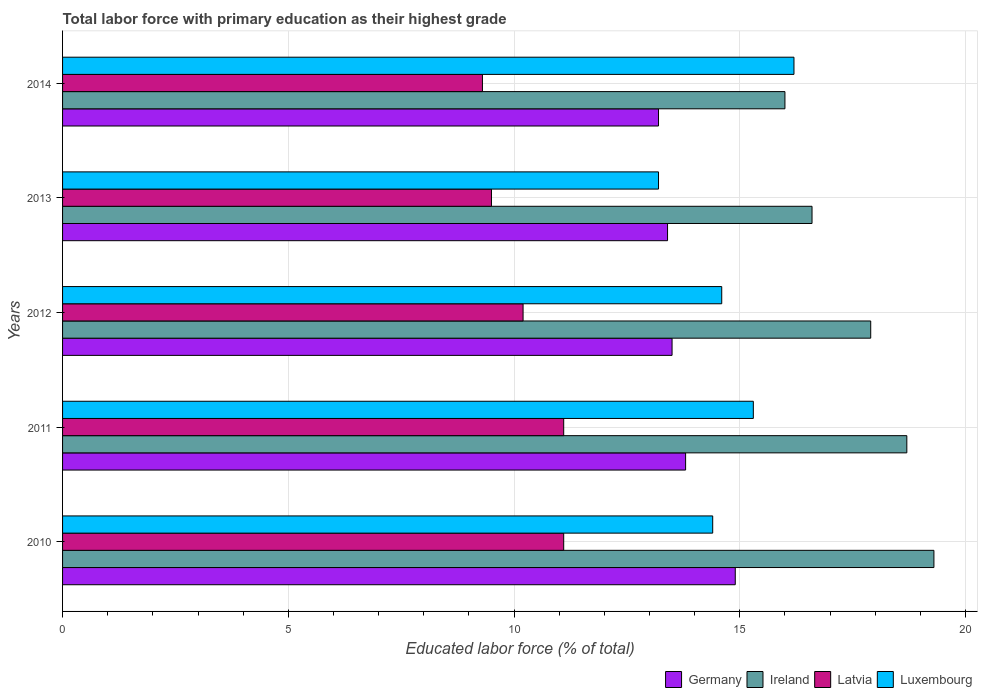How many different coloured bars are there?
Keep it short and to the point. 4. How many groups of bars are there?
Provide a succinct answer. 5. Are the number of bars per tick equal to the number of legend labels?
Your answer should be compact. Yes. Are the number of bars on each tick of the Y-axis equal?
Your response must be concise. Yes. How many bars are there on the 3rd tick from the top?
Your answer should be very brief. 4. How many bars are there on the 5th tick from the bottom?
Provide a short and direct response. 4. What is the label of the 3rd group of bars from the top?
Give a very brief answer. 2012. What is the percentage of total labor force with primary education in Germany in 2010?
Provide a succinct answer. 14.9. Across all years, what is the maximum percentage of total labor force with primary education in Luxembourg?
Offer a very short reply. 16.2. Across all years, what is the minimum percentage of total labor force with primary education in Luxembourg?
Your response must be concise. 13.2. In which year was the percentage of total labor force with primary education in Luxembourg minimum?
Ensure brevity in your answer.  2013. What is the total percentage of total labor force with primary education in Latvia in the graph?
Your response must be concise. 51.2. What is the difference between the percentage of total labor force with primary education in Germany in 2011 and that in 2014?
Offer a terse response. 0.6. What is the difference between the percentage of total labor force with primary education in Ireland in 2011 and the percentage of total labor force with primary education in Luxembourg in 2014?
Your answer should be very brief. 2.5. What is the average percentage of total labor force with primary education in Ireland per year?
Give a very brief answer. 17.7. In the year 2013, what is the difference between the percentage of total labor force with primary education in Latvia and percentage of total labor force with primary education in Luxembourg?
Make the answer very short. -3.7. What is the ratio of the percentage of total labor force with primary education in Luxembourg in 2010 to that in 2014?
Keep it short and to the point. 0.89. What is the difference between the highest and the second highest percentage of total labor force with primary education in Luxembourg?
Your answer should be very brief. 0.9. What is the difference between the highest and the lowest percentage of total labor force with primary education in Luxembourg?
Offer a very short reply. 3. Is the sum of the percentage of total labor force with primary education in Luxembourg in 2013 and 2014 greater than the maximum percentage of total labor force with primary education in Latvia across all years?
Your answer should be compact. Yes. Is it the case that in every year, the sum of the percentage of total labor force with primary education in Latvia and percentage of total labor force with primary education in Ireland is greater than the sum of percentage of total labor force with primary education in Germany and percentage of total labor force with primary education in Luxembourg?
Ensure brevity in your answer.  No. What does the 3rd bar from the top in 2011 represents?
Your answer should be compact. Ireland. What does the 3rd bar from the bottom in 2014 represents?
Offer a very short reply. Latvia. Is it the case that in every year, the sum of the percentage of total labor force with primary education in Germany and percentage of total labor force with primary education in Latvia is greater than the percentage of total labor force with primary education in Luxembourg?
Make the answer very short. Yes. Are all the bars in the graph horizontal?
Ensure brevity in your answer.  Yes. How many years are there in the graph?
Give a very brief answer. 5. Does the graph contain any zero values?
Provide a succinct answer. No. Where does the legend appear in the graph?
Ensure brevity in your answer.  Bottom right. What is the title of the graph?
Provide a succinct answer. Total labor force with primary education as their highest grade. What is the label or title of the X-axis?
Your response must be concise. Educated labor force (% of total). What is the Educated labor force (% of total) of Germany in 2010?
Your answer should be very brief. 14.9. What is the Educated labor force (% of total) of Ireland in 2010?
Your answer should be very brief. 19.3. What is the Educated labor force (% of total) in Latvia in 2010?
Your answer should be very brief. 11.1. What is the Educated labor force (% of total) in Luxembourg in 2010?
Keep it short and to the point. 14.4. What is the Educated labor force (% of total) of Germany in 2011?
Give a very brief answer. 13.8. What is the Educated labor force (% of total) in Ireland in 2011?
Offer a terse response. 18.7. What is the Educated labor force (% of total) of Latvia in 2011?
Your answer should be compact. 11.1. What is the Educated labor force (% of total) of Luxembourg in 2011?
Your answer should be compact. 15.3. What is the Educated labor force (% of total) of Germany in 2012?
Your answer should be compact. 13.5. What is the Educated labor force (% of total) in Ireland in 2012?
Make the answer very short. 17.9. What is the Educated labor force (% of total) in Latvia in 2012?
Provide a short and direct response. 10.2. What is the Educated labor force (% of total) of Luxembourg in 2012?
Make the answer very short. 14.6. What is the Educated labor force (% of total) in Germany in 2013?
Your answer should be very brief. 13.4. What is the Educated labor force (% of total) in Ireland in 2013?
Keep it short and to the point. 16.6. What is the Educated labor force (% of total) of Luxembourg in 2013?
Give a very brief answer. 13.2. What is the Educated labor force (% of total) of Germany in 2014?
Give a very brief answer. 13.2. What is the Educated labor force (% of total) of Latvia in 2014?
Offer a terse response. 9.3. What is the Educated labor force (% of total) in Luxembourg in 2014?
Your answer should be compact. 16.2. Across all years, what is the maximum Educated labor force (% of total) of Germany?
Offer a very short reply. 14.9. Across all years, what is the maximum Educated labor force (% of total) of Ireland?
Make the answer very short. 19.3. Across all years, what is the maximum Educated labor force (% of total) of Latvia?
Offer a terse response. 11.1. Across all years, what is the maximum Educated labor force (% of total) of Luxembourg?
Give a very brief answer. 16.2. Across all years, what is the minimum Educated labor force (% of total) in Germany?
Your answer should be compact. 13.2. Across all years, what is the minimum Educated labor force (% of total) of Ireland?
Make the answer very short. 16. Across all years, what is the minimum Educated labor force (% of total) in Latvia?
Your answer should be compact. 9.3. Across all years, what is the minimum Educated labor force (% of total) in Luxembourg?
Your response must be concise. 13.2. What is the total Educated labor force (% of total) in Germany in the graph?
Provide a short and direct response. 68.8. What is the total Educated labor force (% of total) of Ireland in the graph?
Offer a terse response. 88.5. What is the total Educated labor force (% of total) of Latvia in the graph?
Provide a short and direct response. 51.2. What is the total Educated labor force (% of total) of Luxembourg in the graph?
Your response must be concise. 73.7. What is the difference between the Educated labor force (% of total) in Germany in 2010 and that in 2011?
Make the answer very short. 1.1. What is the difference between the Educated labor force (% of total) in Latvia in 2010 and that in 2011?
Provide a short and direct response. 0. What is the difference between the Educated labor force (% of total) in Germany in 2010 and that in 2013?
Provide a succinct answer. 1.5. What is the difference between the Educated labor force (% of total) of Latvia in 2010 and that in 2013?
Your response must be concise. 1.6. What is the difference between the Educated labor force (% of total) in Luxembourg in 2010 and that in 2013?
Offer a terse response. 1.2. What is the difference between the Educated labor force (% of total) of Ireland in 2010 and that in 2014?
Ensure brevity in your answer.  3.3. What is the difference between the Educated labor force (% of total) in Germany in 2011 and that in 2012?
Offer a very short reply. 0.3. What is the difference between the Educated labor force (% of total) in Latvia in 2011 and that in 2012?
Provide a short and direct response. 0.9. What is the difference between the Educated labor force (% of total) in Luxembourg in 2011 and that in 2012?
Ensure brevity in your answer.  0.7. What is the difference between the Educated labor force (% of total) of Ireland in 2011 and that in 2014?
Make the answer very short. 2.7. What is the difference between the Educated labor force (% of total) of Germany in 2012 and that in 2013?
Offer a very short reply. 0.1. What is the difference between the Educated labor force (% of total) of Latvia in 2012 and that in 2014?
Give a very brief answer. 0.9. What is the difference between the Educated labor force (% of total) in Luxembourg in 2012 and that in 2014?
Your answer should be very brief. -1.6. What is the difference between the Educated labor force (% of total) of Germany in 2013 and that in 2014?
Ensure brevity in your answer.  0.2. What is the difference between the Educated labor force (% of total) in Latvia in 2013 and that in 2014?
Offer a very short reply. 0.2. What is the difference between the Educated labor force (% of total) of Luxembourg in 2013 and that in 2014?
Provide a succinct answer. -3. What is the difference between the Educated labor force (% of total) of Ireland in 2010 and the Educated labor force (% of total) of Latvia in 2011?
Give a very brief answer. 8.2. What is the difference between the Educated labor force (% of total) of Germany in 2010 and the Educated labor force (% of total) of Ireland in 2012?
Ensure brevity in your answer.  -3. What is the difference between the Educated labor force (% of total) in Germany in 2010 and the Educated labor force (% of total) in Latvia in 2012?
Your answer should be very brief. 4.7. What is the difference between the Educated labor force (% of total) in Ireland in 2010 and the Educated labor force (% of total) in Latvia in 2012?
Keep it short and to the point. 9.1. What is the difference between the Educated labor force (% of total) in Ireland in 2010 and the Educated labor force (% of total) in Luxembourg in 2012?
Offer a terse response. 4.7. What is the difference between the Educated labor force (% of total) in Latvia in 2010 and the Educated labor force (% of total) in Luxembourg in 2012?
Your answer should be compact. -3.5. What is the difference between the Educated labor force (% of total) in Germany in 2010 and the Educated labor force (% of total) in Ireland in 2013?
Your answer should be compact. -1.7. What is the difference between the Educated labor force (% of total) of Germany in 2010 and the Educated labor force (% of total) of Latvia in 2013?
Ensure brevity in your answer.  5.4. What is the difference between the Educated labor force (% of total) in Germany in 2010 and the Educated labor force (% of total) in Luxembourg in 2013?
Keep it short and to the point. 1.7. What is the difference between the Educated labor force (% of total) of Ireland in 2010 and the Educated labor force (% of total) of Latvia in 2013?
Offer a terse response. 9.8. What is the difference between the Educated labor force (% of total) of Latvia in 2010 and the Educated labor force (% of total) of Luxembourg in 2013?
Offer a terse response. -2.1. What is the difference between the Educated labor force (% of total) of Germany in 2010 and the Educated labor force (% of total) of Ireland in 2014?
Make the answer very short. -1.1. What is the difference between the Educated labor force (% of total) in Germany in 2010 and the Educated labor force (% of total) in Latvia in 2014?
Your response must be concise. 5.6. What is the difference between the Educated labor force (% of total) in Ireland in 2010 and the Educated labor force (% of total) in Latvia in 2014?
Keep it short and to the point. 10. What is the difference between the Educated labor force (% of total) of Latvia in 2010 and the Educated labor force (% of total) of Luxembourg in 2014?
Your answer should be compact. -5.1. What is the difference between the Educated labor force (% of total) in Germany in 2011 and the Educated labor force (% of total) in Ireland in 2012?
Keep it short and to the point. -4.1. What is the difference between the Educated labor force (% of total) in Germany in 2011 and the Educated labor force (% of total) in Luxembourg in 2012?
Your response must be concise. -0.8. What is the difference between the Educated labor force (% of total) in Ireland in 2011 and the Educated labor force (% of total) in Latvia in 2012?
Provide a succinct answer. 8.5. What is the difference between the Educated labor force (% of total) of Ireland in 2011 and the Educated labor force (% of total) of Luxembourg in 2012?
Offer a very short reply. 4.1. What is the difference between the Educated labor force (% of total) of Germany in 2011 and the Educated labor force (% of total) of Ireland in 2013?
Offer a terse response. -2.8. What is the difference between the Educated labor force (% of total) in Ireland in 2011 and the Educated labor force (% of total) in Luxembourg in 2013?
Provide a short and direct response. 5.5. What is the difference between the Educated labor force (% of total) in Germany in 2011 and the Educated labor force (% of total) in Luxembourg in 2014?
Your answer should be very brief. -2.4. What is the difference between the Educated labor force (% of total) of Ireland in 2011 and the Educated labor force (% of total) of Luxembourg in 2014?
Your answer should be compact. 2.5. What is the difference between the Educated labor force (% of total) of Germany in 2012 and the Educated labor force (% of total) of Ireland in 2013?
Provide a succinct answer. -3.1. What is the difference between the Educated labor force (% of total) of Germany in 2012 and the Educated labor force (% of total) of Latvia in 2013?
Give a very brief answer. 4. What is the difference between the Educated labor force (% of total) of Germany in 2012 and the Educated labor force (% of total) of Luxembourg in 2013?
Give a very brief answer. 0.3. What is the difference between the Educated labor force (% of total) in Ireland in 2012 and the Educated labor force (% of total) in Latvia in 2013?
Your response must be concise. 8.4. What is the difference between the Educated labor force (% of total) of Ireland in 2012 and the Educated labor force (% of total) of Luxembourg in 2013?
Ensure brevity in your answer.  4.7. What is the difference between the Educated labor force (% of total) of Latvia in 2012 and the Educated labor force (% of total) of Luxembourg in 2013?
Make the answer very short. -3. What is the difference between the Educated labor force (% of total) of Germany in 2012 and the Educated labor force (% of total) of Latvia in 2014?
Keep it short and to the point. 4.2. What is the difference between the Educated labor force (% of total) of Germany in 2012 and the Educated labor force (% of total) of Luxembourg in 2014?
Give a very brief answer. -2.7. What is the difference between the Educated labor force (% of total) in Ireland in 2012 and the Educated labor force (% of total) in Latvia in 2014?
Offer a terse response. 8.6. What is the difference between the Educated labor force (% of total) of Latvia in 2012 and the Educated labor force (% of total) of Luxembourg in 2014?
Your answer should be very brief. -6. What is the difference between the Educated labor force (% of total) in Germany in 2013 and the Educated labor force (% of total) in Latvia in 2014?
Ensure brevity in your answer.  4.1. What is the difference between the Educated labor force (% of total) of Ireland in 2013 and the Educated labor force (% of total) of Luxembourg in 2014?
Your answer should be compact. 0.4. What is the difference between the Educated labor force (% of total) of Latvia in 2013 and the Educated labor force (% of total) of Luxembourg in 2014?
Make the answer very short. -6.7. What is the average Educated labor force (% of total) of Germany per year?
Offer a terse response. 13.76. What is the average Educated labor force (% of total) of Latvia per year?
Make the answer very short. 10.24. What is the average Educated labor force (% of total) of Luxembourg per year?
Your answer should be very brief. 14.74. In the year 2010, what is the difference between the Educated labor force (% of total) in Germany and Educated labor force (% of total) in Ireland?
Your answer should be compact. -4.4. In the year 2010, what is the difference between the Educated labor force (% of total) of Germany and Educated labor force (% of total) of Luxembourg?
Provide a short and direct response. 0.5. In the year 2011, what is the difference between the Educated labor force (% of total) in Germany and Educated labor force (% of total) in Latvia?
Give a very brief answer. 2.7. In the year 2011, what is the difference between the Educated labor force (% of total) of Germany and Educated labor force (% of total) of Luxembourg?
Ensure brevity in your answer.  -1.5. In the year 2011, what is the difference between the Educated labor force (% of total) of Ireland and Educated labor force (% of total) of Luxembourg?
Ensure brevity in your answer.  3.4. In the year 2011, what is the difference between the Educated labor force (% of total) in Latvia and Educated labor force (% of total) in Luxembourg?
Your answer should be compact. -4.2. In the year 2012, what is the difference between the Educated labor force (% of total) of Germany and Educated labor force (% of total) of Ireland?
Offer a terse response. -4.4. In the year 2012, what is the difference between the Educated labor force (% of total) in Germany and Educated labor force (% of total) in Luxembourg?
Ensure brevity in your answer.  -1.1. In the year 2012, what is the difference between the Educated labor force (% of total) in Ireland and Educated labor force (% of total) in Luxembourg?
Offer a terse response. 3.3. In the year 2012, what is the difference between the Educated labor force (% of total) in Latvia and Educated labor force (% of total) in Luxembourg?
Keep it short and to the point. -4.4. In the year 2013, what is the difference between the Educated labor force (% of total) of Ireland and Educated labor force (% of total) of Latvia?
Make the answer very short. 7.1. In the year 2013, what is the difference between the Educated labor force (% of total) of Ireland and Educated labor force (% of total) of Luxembourg?
Provide a succinct answer. 3.4. In the year 2013, what is the difference between the Educated labor force (% of total) of Latvia and Educated labor force (% of total) of Luxembourg?
Offer a terse response. -3.7. In the year 2014, what is the difference between the Educated labor force (% of total) in Germany and Educated labor force (% of total) in Ireland?
Offer a terse response. -2.8. In the year 2014, what is the difference between the Educated labor force (% of total) in Germany and Educated labor force (% of total) in Luxembourg?
Your response must be concise. -3. What is the ratio of the Educated labor force (% of total) of Germany in 2010 to that in 2011?
Provide a succinct answer. 1.08. What is the ratio of the Educated labor force (% of total) of Ireland in 2010 to that in 2011?
Ensure brevity in your answer.  1.03. What is the ratio of the Educated labor force (% of total) of Luxembourg in 2010 to that in 2011?
Your answer should be compact. 0.94. What is the ratio of the Educated labor force (% of total) of Germany in 2010 to that in 2012?
Make the answer very short. 1.1. What is the ratio of the Educated labor force (% of total) in Ireland in 2010 to that in 2012?
Keep it short and to the point. 1.08. What is the ratio of the Educated labor force (% of total) of Latvia in 2010 to that in 2012?
Provide a succinct answer. 1.09. What is the ratio of the Educated labor force (% of total) of Luxembourg in 2010 to that in 2012?
Your answer should be compact. 0.99. What is the ratio of the Educated labor force (% of total) of Germany in 2010 to that in 2013?
Provide a short and direct response. 1.11. What is the ratio of the Educated labor force (% of total) in Ireland in 2010 to that in 2013?
Ensure brevity in your answer.  1.16. What is the ratio of the Educated labor force (% of total) in Latvia in 2010 to that in 2013?
Provide a succinct answer. 1.17. What is the ratio of the Educated labor force (% of total) in Luxembourg in 2010 to that in 2013?
Your response must be concise. 1.09. What is the ratio of the Educated labor force (% of total) in Germany in 2010 to that in 2014?
Provide a succinct answer. 1.13. What is the ratio of the Educated labor force (% of total) of Ireland in 2010 to that in 2014?
Your response must be concise. 1.21. What is the ratio of the Educated labor force (% of total) in Latvia in 2010 to that in 2014?
Provide a succinct answer. 1.19. What is the ratio of the Educated labor force (% of total) in Germany in 2011 to that in 2012?
Ensure brevity in your answer.  1.02. What is the ratio of the Educated labor force (% of total) in Ireland in 2011 to that in 2012?
Make the answer very short. 1.04. What is the ratio of the Educated labor force (% of total) in Latvia in 2011 to that in 2012?
Give a very brief answer. 1.09. What is the ratio of the Educated labor force (% of total) in Luxembourg in 2011 to that in 2012?
Give a very brief answer. 1.05. What is the ratio of the Educated labor force (% of total) in Germany in 2011 to that in 2013?
Offer a terse response. 1.03. What is the ratio of the Educated labor force (% of total) in Ireland in 2011 to that in 2013?
Provide a succinct answer. 1.13. What is the ratio of the Educated labor force (% of total) of Latvia in 2011 to that in 2013?
Provide a succinct answer. 1.17. What is the ratio of the Educated labor force (% of total) of Luxembourg in 2011 to that in 2013?
Make the answer very short. 1.16. What is the ratio of the Educated labor force (% of total) in Germany in 2011 to that in 2014?
Ensure brevity in your answer.  1.05. What is the ratio of the Educated labor force (% of total) of Ireland in 2011 to that in 2014?
Keep it short and to the point. 1.17. What is the ratio of the Educated labor force (% of total) in Latvia in 2011 to that in 2014?
Ensure brevity in your answer.  1.19. What is the ratio of the Educated labor force (% of total) in Luxembourg in 2011 to that in 2014?
Give a very brief answer. 0.94. What is the ratio of the Educated labor force (% of total) of Germany in 2012 to that in 2013?
Provide a short and direct response. 1.01. What is the ratio of the Educated labor force (% of total) of Ireland in 2012 to that in 2013?
Your answer should be compact. 1.08. What is the ratio of the Educated labor force (% of total) of Latvia in 2012 to that in 2013?
Give a very brief answer. 1.07. What is the ratio of the Educated labor force (% of total) of Luxembourg in 2012 to that in 2013?
Make the answer very short. 1.11. What is the ratio of the Educated labor force (% of total) in Germany in 2012 to that in 2014?
Your answer should be very brief. 1.02. What is the ratio of the Educated labor force (% of total) in Ireland in 2012 to that in 2014?
Your answer should be compact. 1.12. What is the ratio of the Educated labor force (% of total) of Latvia in 2012 to that in 2014?
Provide a short and direct response. 1.1. What is the ratio of the Educated labor force (% of total) of Luxembourg in 2012 to that in 2014?
Offer a very short reply. 0.9. What is the ratio of the Educated labor force (% of total) of Germany in 2013 to that in 2014?
Keep it short and to the point. 1.02. What is the ratio of the Educated labor force (% of total) of Ireland in 2013 to that in 2014?
Ensure brevity in your answer.  1.04. What is the ratio of the Educated labor force (% of total) of Latvia in 2013 to that in 2014?
Offer a terse response. 1.02. What is the ratio of the Educated labor force (% of total) in Luxembourg in 2013 to that in 2014?
Offer a very short reply. 0.81. What is the difference between the highest and the second highest Educated labor force (% of total) of Germany?
Offer a terse response. 1.1. What is the difference between the highest and the second highest Educated labor force (% of total) in Latvia?
Ensure brevity in your answer.  0. What is the difference between the highest and the lowest Educated labor force (% of total) of Ireland?
Give a very brief answer. 3.3. What is the difference between the highest and the lowest Educated labor force (% of total) in Latvia?
Provide a short and direct response. 1.8. What is the difference between the highest and the lowest Educated labor force (% of total) of Luxembourg?
Your answer should be very brief. 3. 